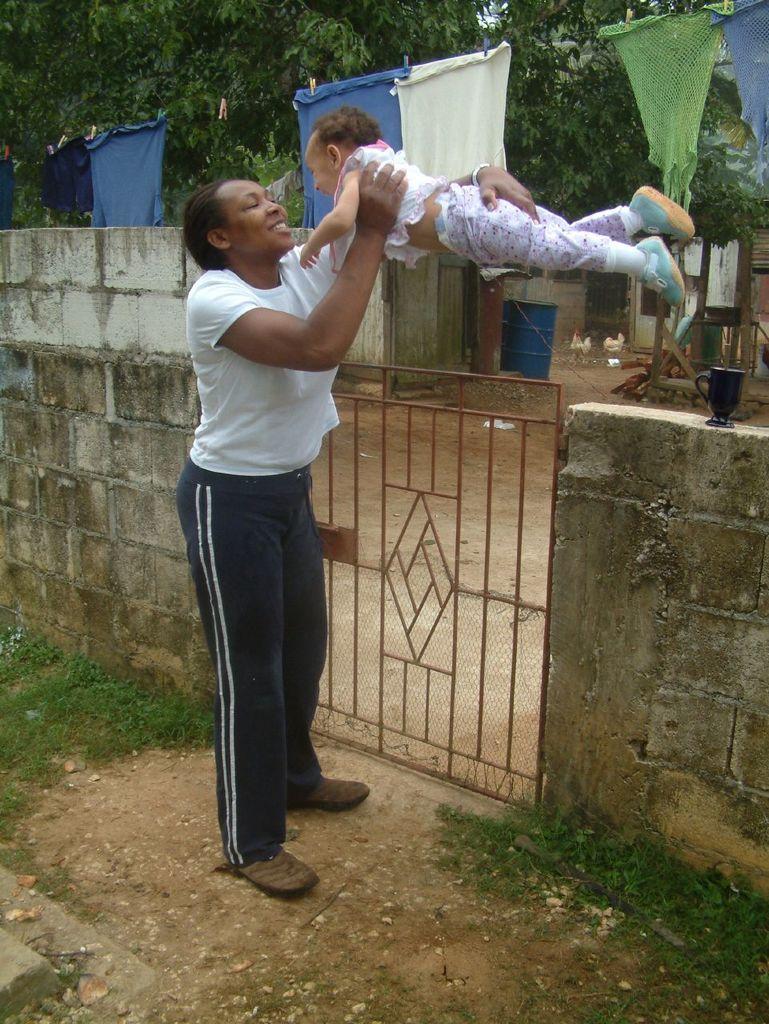Please provide a concise description of this image. In this image we can see a woman holding baby in her hands, mesh, shredded leaves on the ground, grass, building, drums, hens, clothes hanged to the rope and trees. 